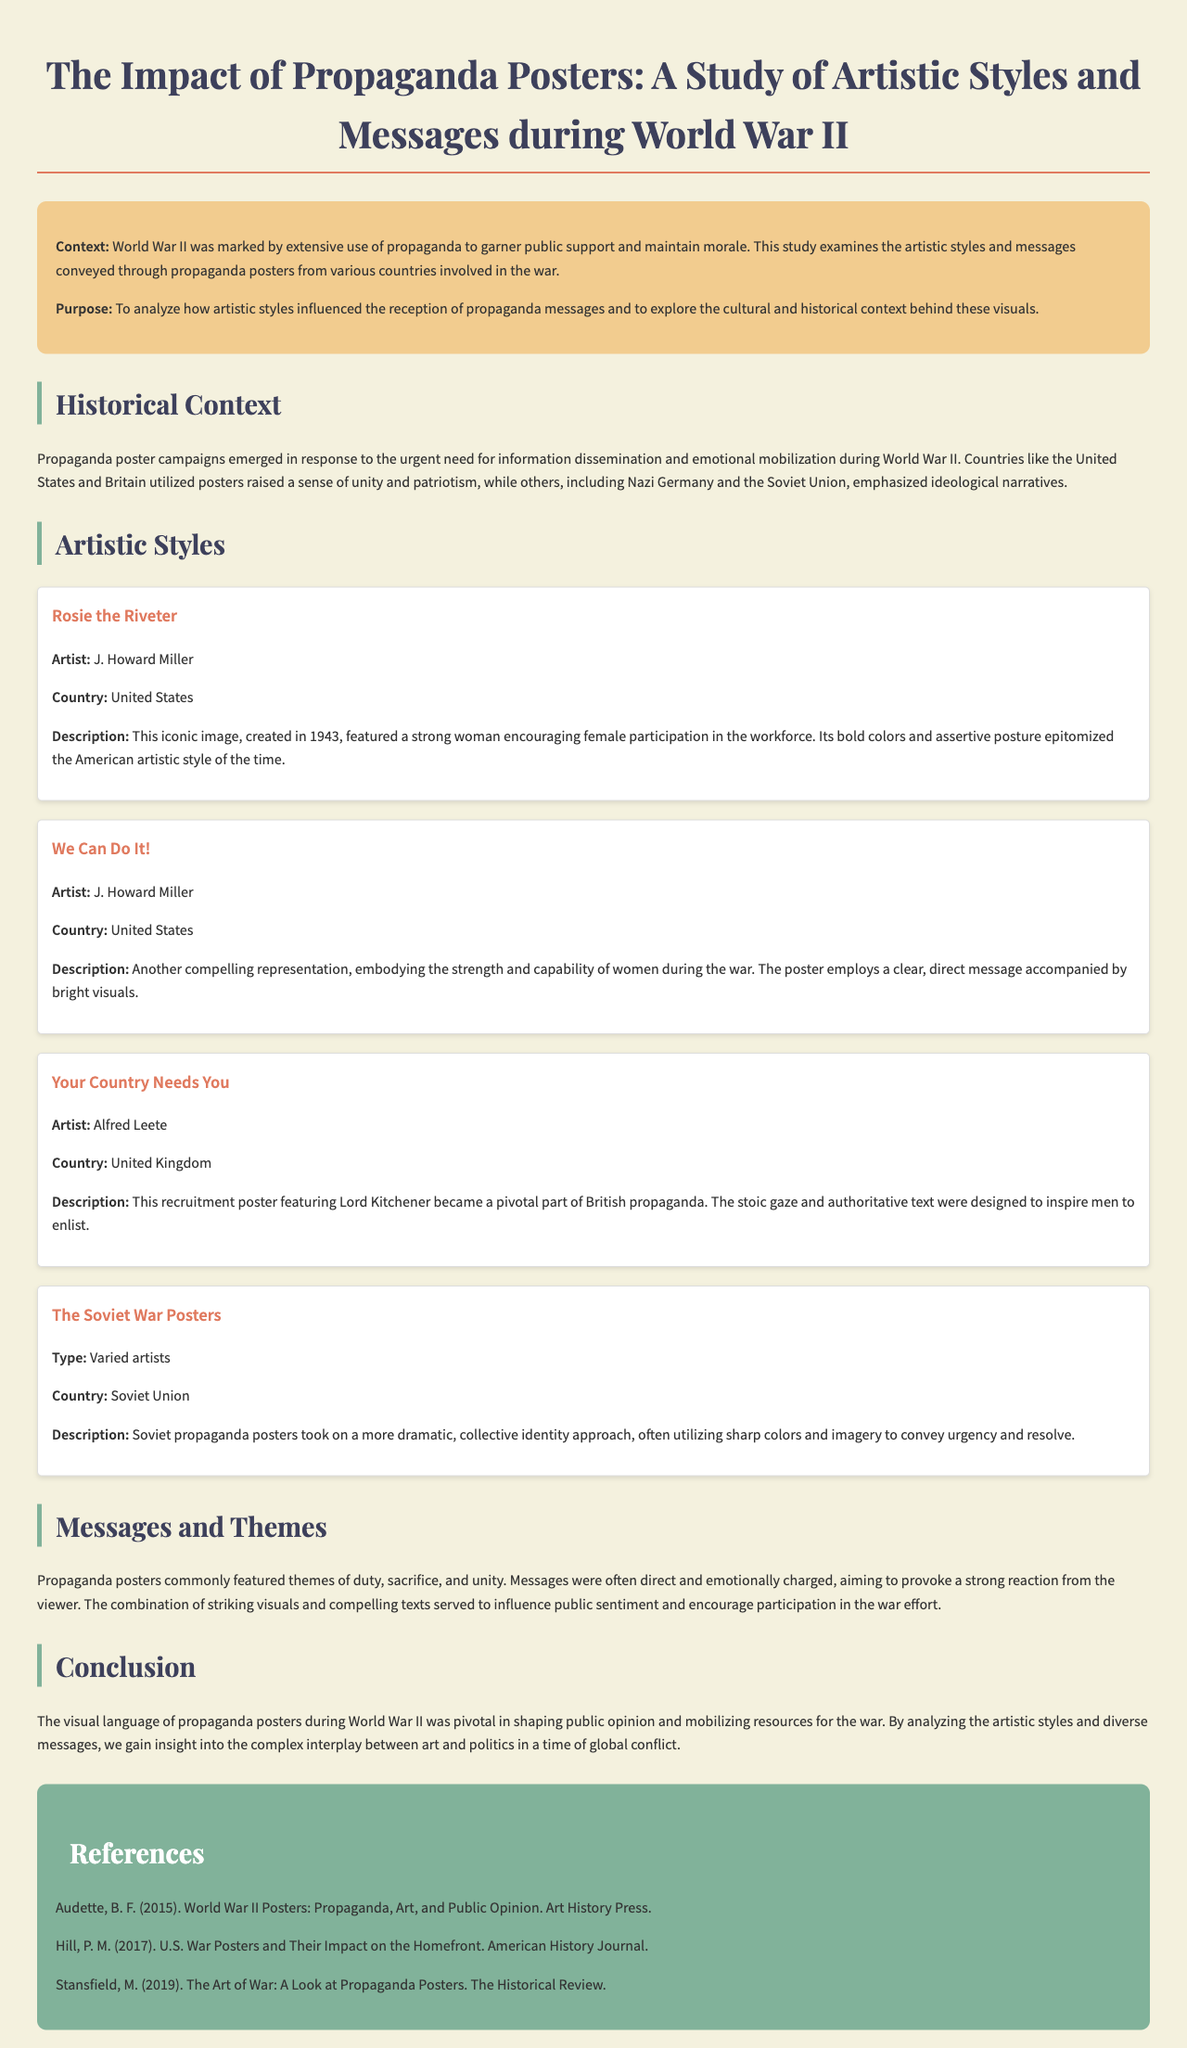What is the title of the document? The title is mentioned at the beginning of the document.
Answer: The Impact of Propaganda Posters: A Study of Artistic Styles and Messages during World War II Who is the artist of the "We Can Do It!" poster? The artist's name is provided in the section detailing the poster examples.
Answer: J. Howard Miller Which country created the "Your Country Needs You" poster? The country associated with the poster is stated alongside the poster details.
Answer: United Kingdom What year was the "Rosie the Riveter" poster created? The year of creation is specified in the description of the poster.
Answer: 1943 What are the common themes featured in the propaganda posters? The themes are listed in the section discussing messages and themes.
Answer: Duty, sacrifice, and unity What type of artistic style did Soviet propaganda posters utilize? The document describes the style employed by Soviet posters.
Answer: Dramatic, collective identity approach How many references are included in the document? The total references can be counted in the references section.
Answer: Three What effect did propaganda posters aim to provoke in viewers? The document outlines the intended emotional impact of the posters.
Answer: Strong reaction 